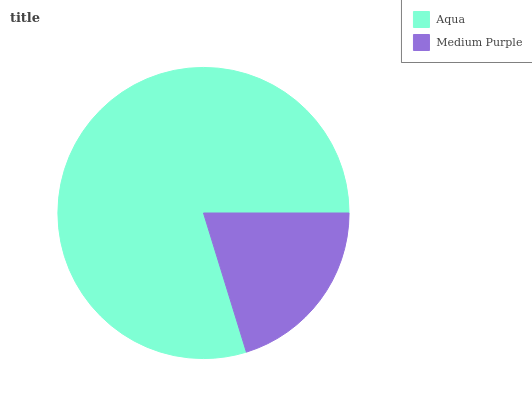Is Medium Purple the minimum?
Answer yes or no. Yes. Is Aqua the maximum?
Answer yes or no. Yes. Is Medium Purple the maximum?
Answer yes or no. No. Is Aqua greater than Medium Purple?
Answer yes or no. Yes. Is Medium Purple less than Aqua?
Answer yes or no. Yes. Is Medium Purple greater than Aqua?
Answer yes or no. No. Is Aqua less than Medium Purple?
Answer yes or no. No. Is Aqua the high median?
Answer yes or no. Yes. Is Medium Purple the low median?
Answer yes or no. Yes. Is Medium Purple the high median?
Answer yes or no. No. Is Aqua the low median?
Answer yes or no. No. 